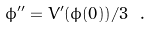<formula> <loc_0><loc_0><loc_500><loc_500>\phi ^ { \prime \prime } = V ^ { \prime } ( \phi ( 0 ) ) / 3 \ .</formula> 